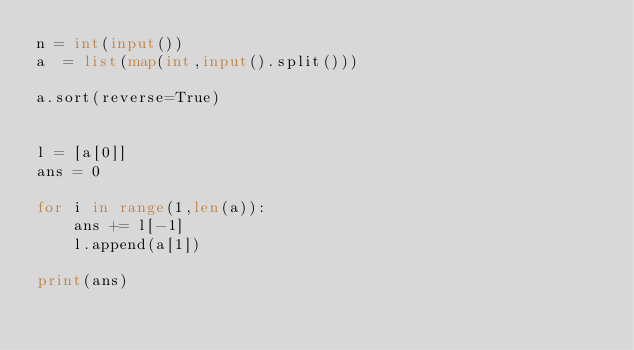<code> <loc_0><loc_0><loc_500><loc_500><_Python_>n = int(input())
a  = list(map(int,input().split()))

a.sort(reverse=True)


l = [a[0]]
ans = 0

for i in range(1,len(a)):
    ans += l[-1]
    l.append(a[1])

print(ans)</code> 